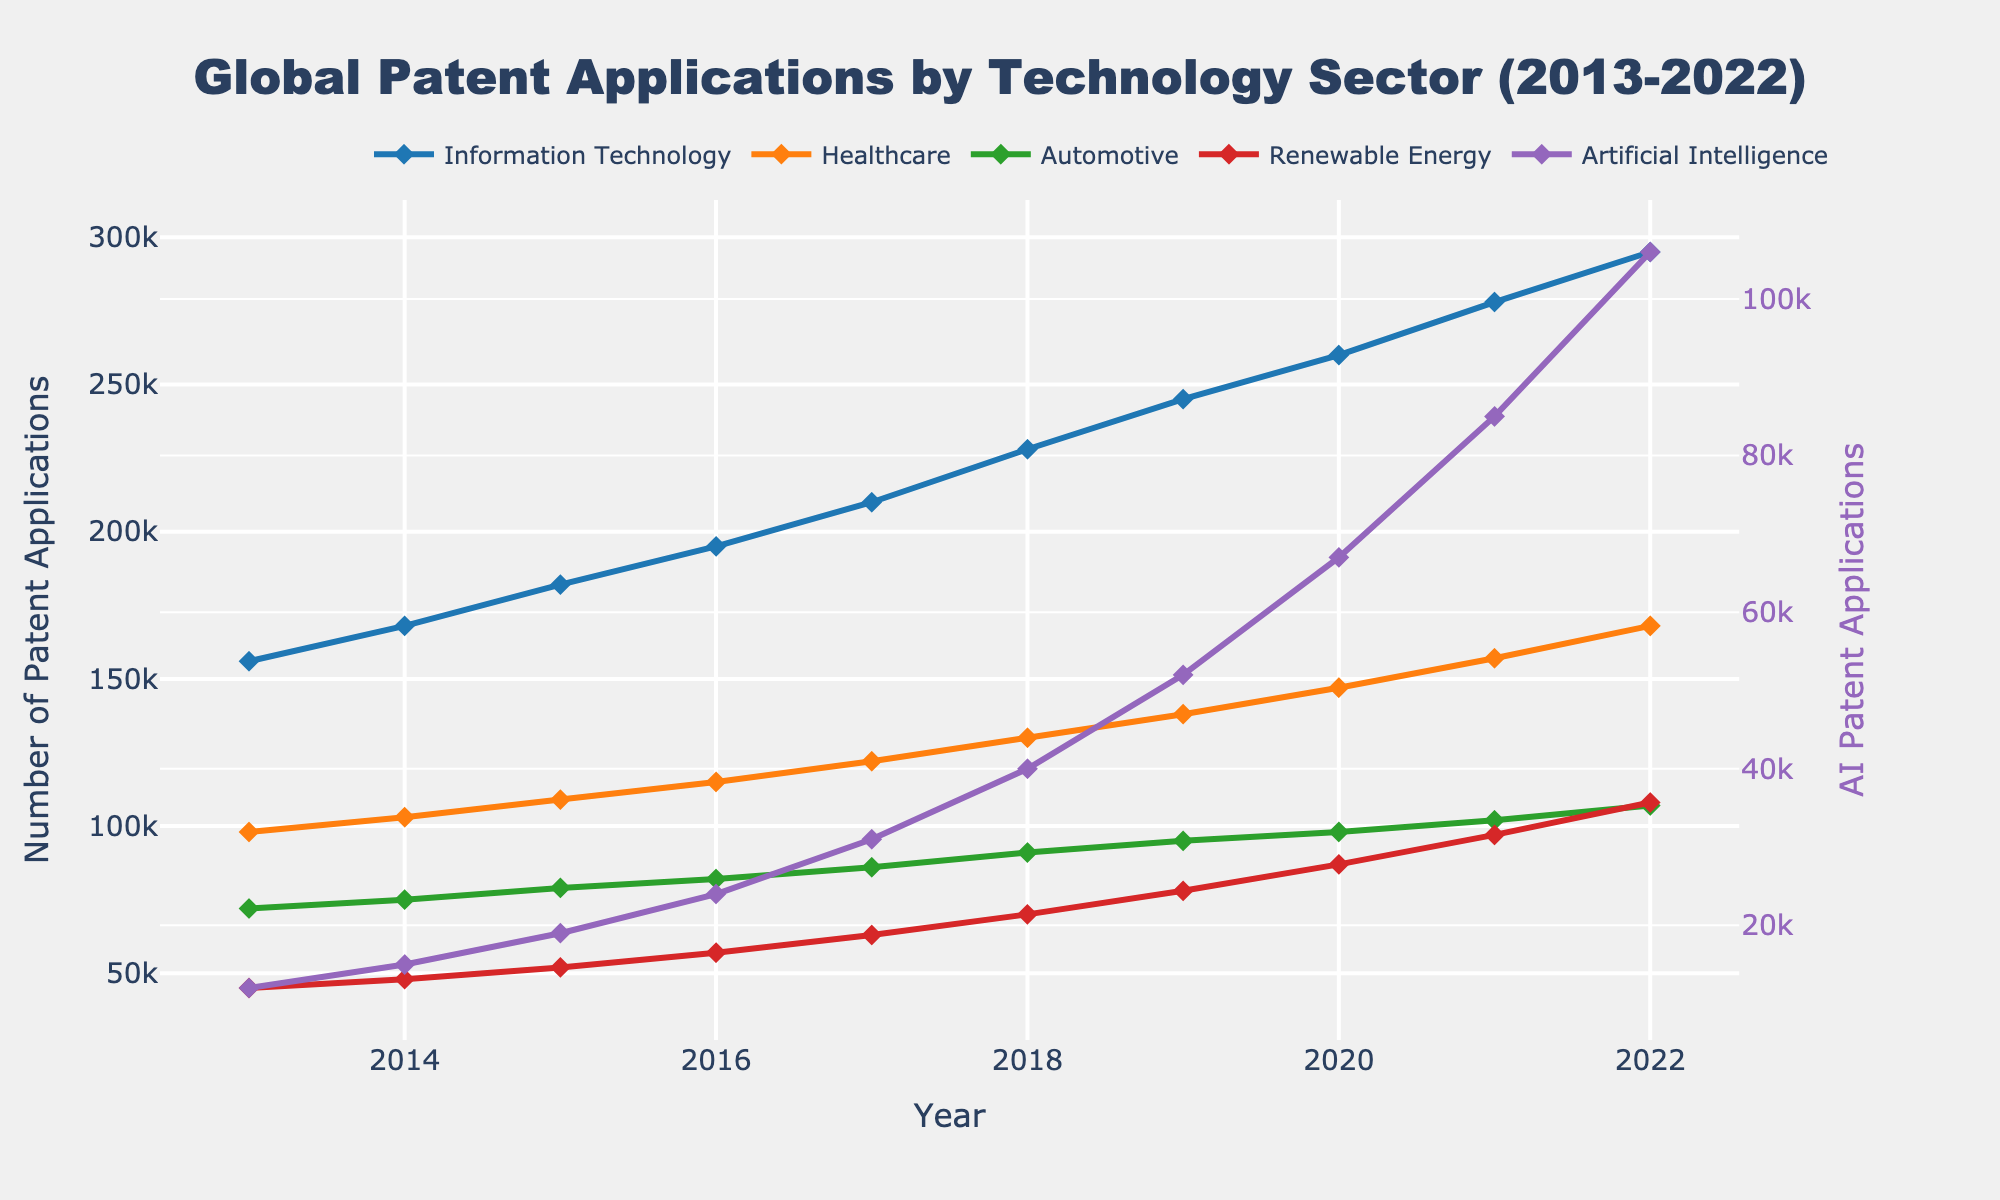What is the overall trend in patent applications for Information Technology (IT) from 2013 to 2022? The line representing IT patent applications shows an upward trend from 2013 to 2022. It starts at 156,000 in 2013 and increases steadily each year until it reaches 295,000 in 2022.
Answer: Upward trend Which technology sector shows the steepest growth in patent applications over the decade? To determine the steepest growth, observe the slopes of the lines for each sector. The line for Artificial Intelligence (AI) shows the steepest incline, starting at 12,000 in 2013 and reaching 106,000 in 2022.
Answer: Artificial Intelligence How do the number of patent applications in Renewable Energy compare to those in Healthcare in 2022? In 2022, the number of patent applications for Renewable Energy and Healthcare can be compared by looking at their respective values. Renewable Energy has 108,000 while Healthcare has 168,000.
Answer: Healthcare has more Which two sectors had the closest number of patent applications in 2017? By examining the values for each sector in 2017, Automotive and Renewable Energy had 86,000 and 63,000 respectively. The closest match in numbers is Automotive and Renewable Energy.
Answer: Automotive and Renewable Energy What is the average number of patent applications for Automotive and Renewable Energy in 2020? For Automotive and Renewable Energy in 2020, add the two values: 98,000 (Automotive) and 87,000 (Renewable Energy), then divide by 2. (98,000 + 87,000) / 2 = 92,500
Answer: 92,500 Which sector's patent applications grew the most between 2020 and 2022? Calculate the difference in the number of patent applications for each sector between 2020 and 2022. AI has the most significant change: 106,000 - 67,000 = 39,000.
Answer: Artificial Intelligence What can you infer about the relative change in patent applications for Healthcare from 2013 to 2022 compared to IT? Calculate the percentage change for both sectors. Healthcare: (168,000 - 98,000) / 98,000 * 100 = 71.43%. IT: (295,000 - 156,000) / 156,000 * 100 = 89.10%. IT had a greater relative change.
Answer: IT had a greater relative change Between which consecutive years did Automotive see the largest increase in patent applications? Look at the differences year-over-year for Automotive. The largest increase is between 2017 and 2018, going from 86,000 to 91,000, an increase of 5,000.
Answer: 2017 to 2018 How does the trend in Artificial Intelligence patent applications compare visually to other sectors? The line for AI patent applications shows a steeper and more rapid increase compared to other sectors, indicating rapid growth in AI relative to others.
Answer: More rapid increase 